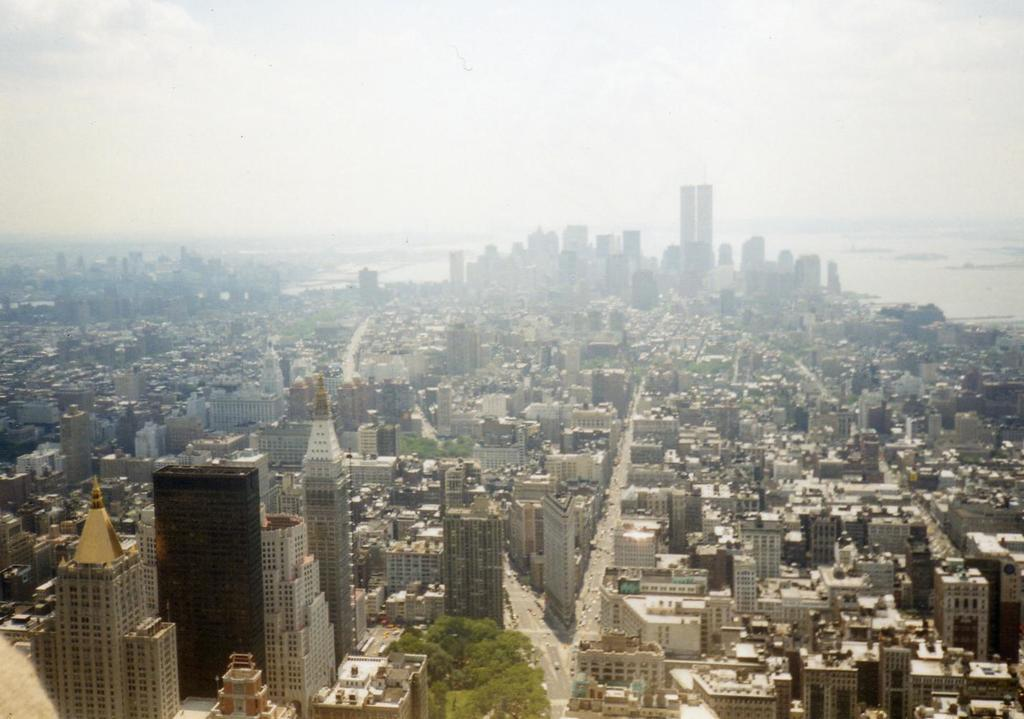What type of structures can be seen in the image? There are buildings in the image, including tower buildings. What else can be seen in the image besides buildings? There are trees and roads visible in the image. What is visible in the sky in the image? Clouds are visible in the sky. What type of lumber is being used to construct the buildings in the image? There is no information about the type of lumber used in the construction of the buildings in the image. Can you see any quills or sofas in the image? No, there are no quills or sofas present in the image. 